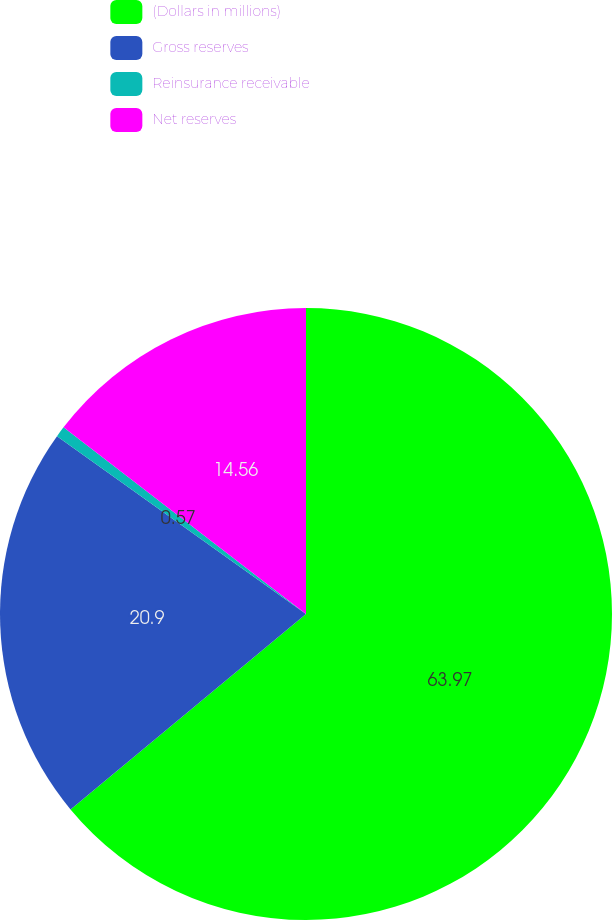Convert chart to OTSL. <chart><loc_0><loc_0><loc_500><loc_500><pie_chart><fcel>(Dollars in millions)<fcel>Gross reserves<fcel>Reinsurance receivable<fcel>Net reserves<nl><fcel>63.98%<fcel>20.9%<fcel>0.57%<fcel>14.56%<nl></chart> 